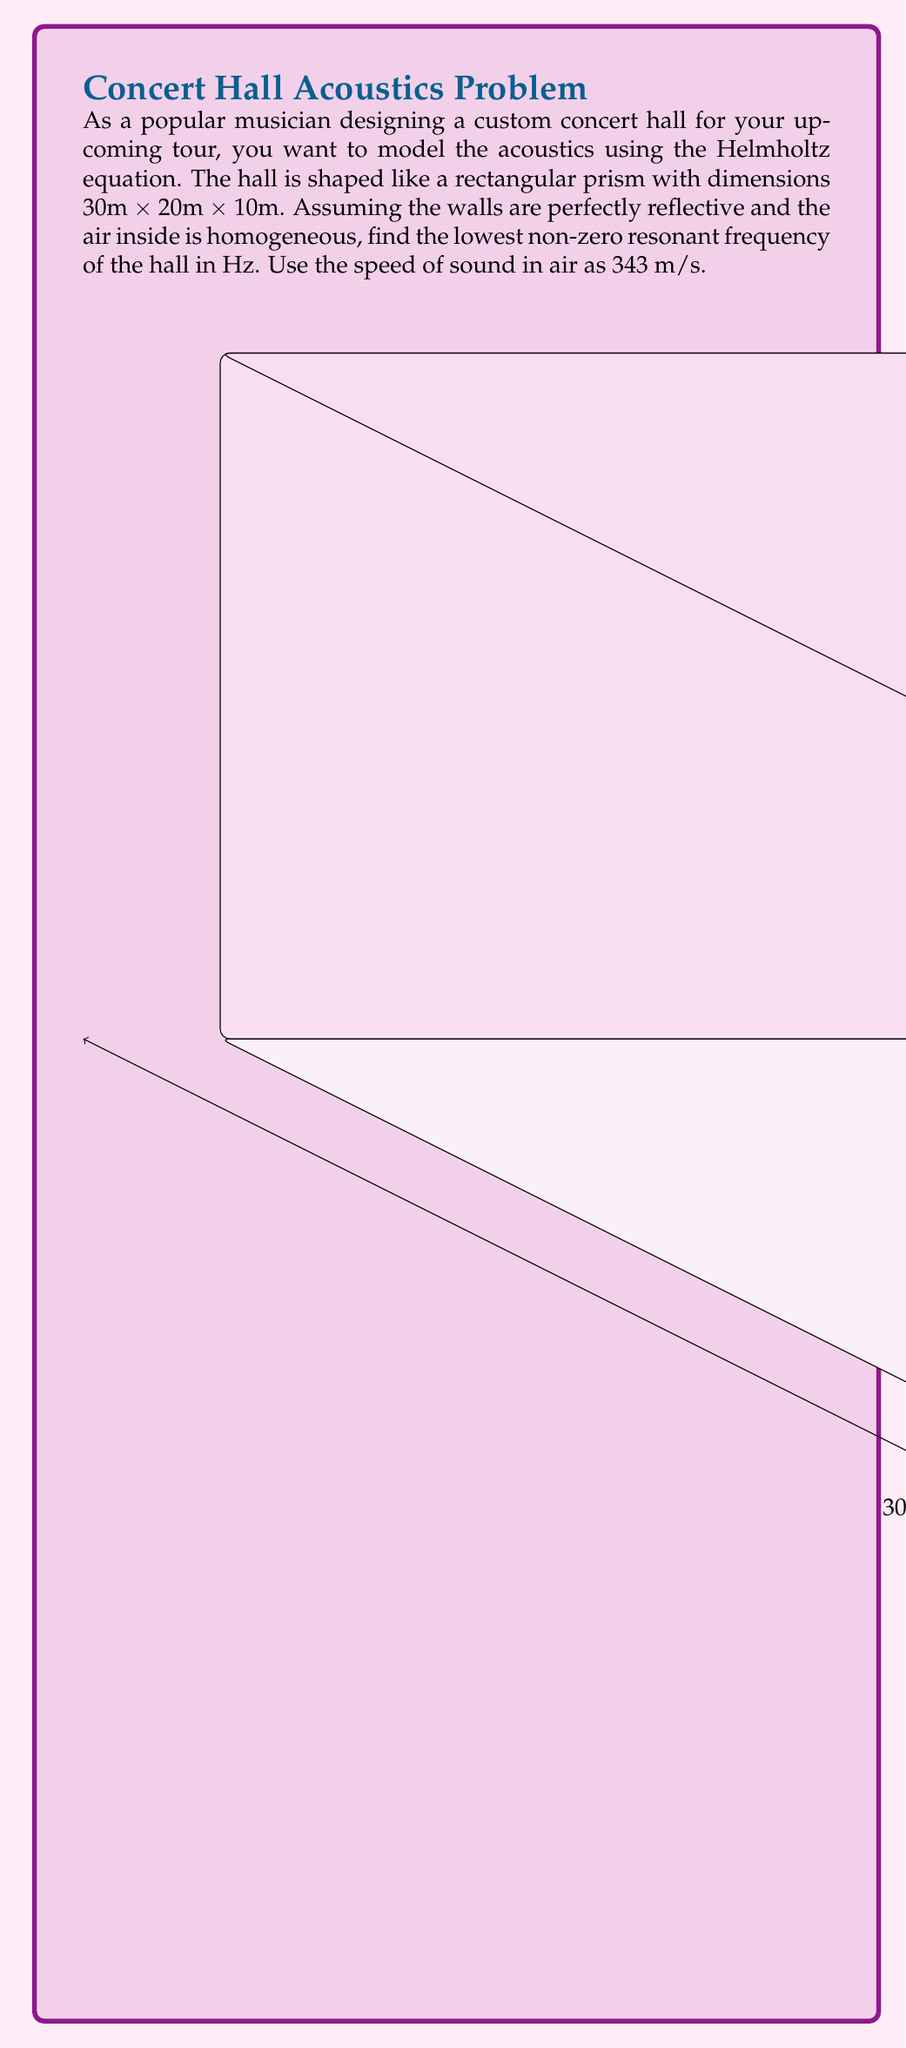Teach me how to tackle this problem. To solve this problem, we'll use the Helmholtz equation and apply boundary conditions for a rectangular room with perfectly reflective walls.

1) The Helmholtz equation is:
   $$\nabla^2 p + k^2 p = 0$$
   where $p$ is the acoustic pressure and $k$ is the wavenumber.

2) For a rectangular room with dimensions $L_x$, $L_y$, and $L_z$, the solution has the form:
   $$p(x,y,z) = A \cos(\frac{n_x \pi x}{L_x}) \cos(\frac{n_y \pi y}{L_y}) \cos(\frac{n_z \pi z}{L_z})$$
   where $n_x$, $n_y$, and $n_z$ are non-negative integers (not all zero).

3) The wavenumber $k$ is related to these integers by:
   $$k^2 = (\frac{n_x \pi}{L_x})^2 + (\frac{n_y \pi}{L_y})^2 + (\frac{n_z \pi}{L_z})^2$$

4) The frequency $f$ is related to the wavenumber $k$ by:
   $$f = \frac{c k}{2\pi}$$
   where $c$ is the speed of sound.

5) Substituting the given dimensions and combining the above equations:
   $$f = \frac{c}{2} \sqrt{(\frac{n_x}{30})^2 + (\frac{n_y}{20})^2 + (\frac{n_z}{10})^2}$$

6) The lowest non-zero resonant frequency occurs when one of $n_x$, $n_y$, or $n_z$ is 1 and the others are 0. The smallest value will be when $n_z = 1$:
   $$f = \frac{343}{2} \sqrt{(\frac{0}{30})^2 + (\frac{0}{20})^2 + (\frac{1}{10})^2} = \frac{343}{20} = 17.15 \text{ Hz}$$
Answer: 17.15 Hz 